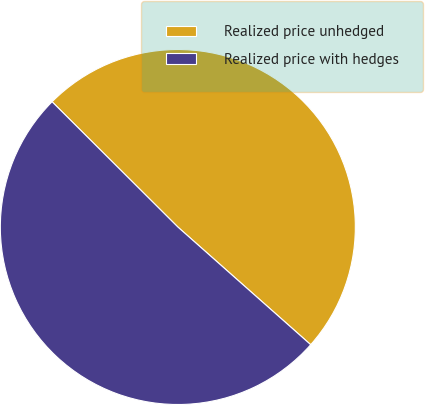<chart> <loc_0><loc_0><loc_500><loc_500><pie_chart><fcel>Realized price unhedged<fcel>Realized price with hedges<nl><fcel>49.07%<fcel>50.93%<nl></chart> 